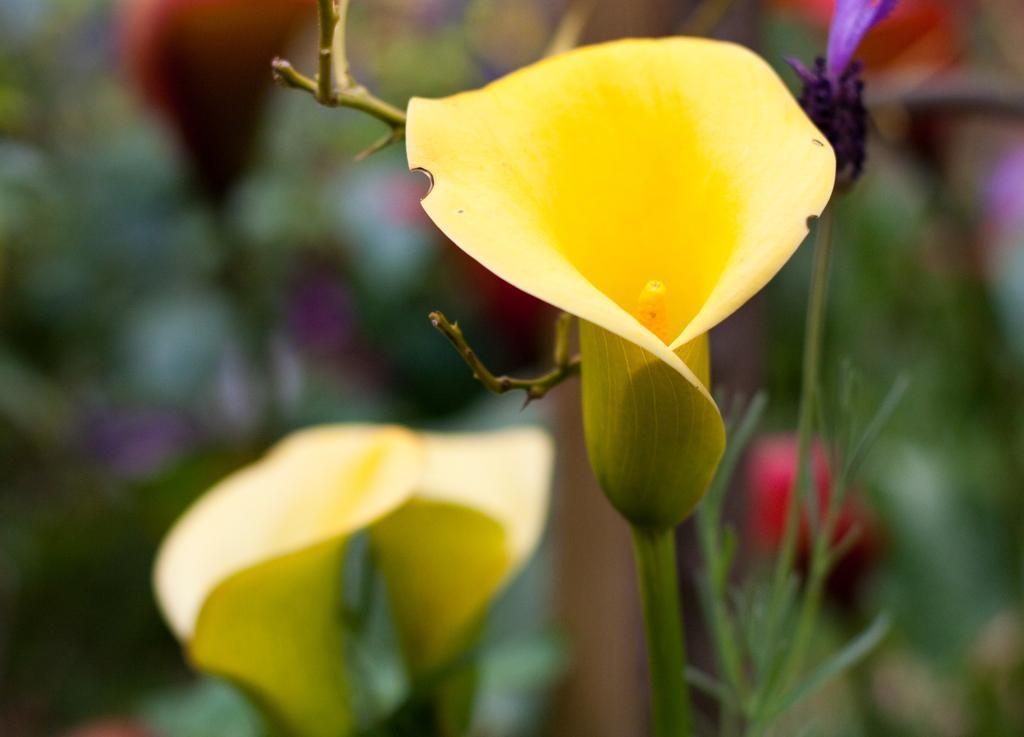In one or two sentences, can you explain what this image depicts? In the center of this picture we can see the yellow color flowers. The background of the image is blurry and we can see the flowers and plants in the background. 